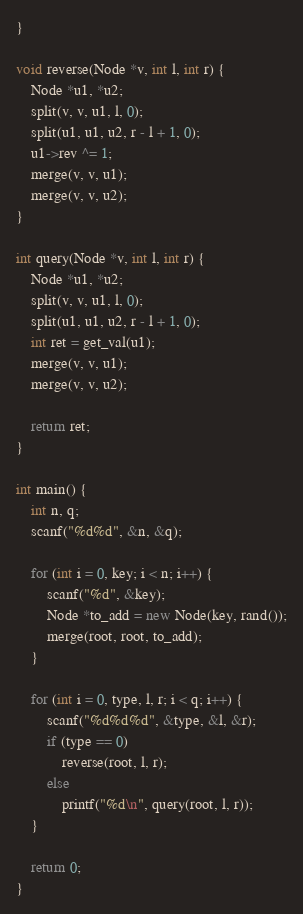<code> <loc_0><loc_0><loc_500><loc_500><_C++_>}

void reverse(Node *v, int l, int r) {
    Node *u1, *u2;
    split(v, v, u1, l, 0);
    split(u1, u1, u2, r - l + 1, 0);
    u1->rev ^= 1;
    merge(v, v, u1);
    merge(v, v, u2);
}

int query(Node *v, int l, int r) {
    Node *u1, *u2;
    split(v, v, u1, l, 0);
    split(u1, u1, u2, r - l + 1, 0);
    int ret = get_val(u1);
    merge(v, v, u1);
    merge(v, v, u2);
    
    return ret;
}

int main() {
    int n, q;
    scanf("%d%d", &n, &q);

    for (int i = 0, key; i < n; i++) {
        scanf("%d", &key);
        Node *to_add = new Node(key, rand());
        merge(root, root, to_add);
    }

    for (int i = 0, type, l, r; i < q; i++) {
        scanf("%d%d%d", &type, &l, &r);
        if (type == 0)
            reverse(root, l, r);
        else
            printf("%d\n", query(root, l, r));
    }

    return 0;
}
</code> 